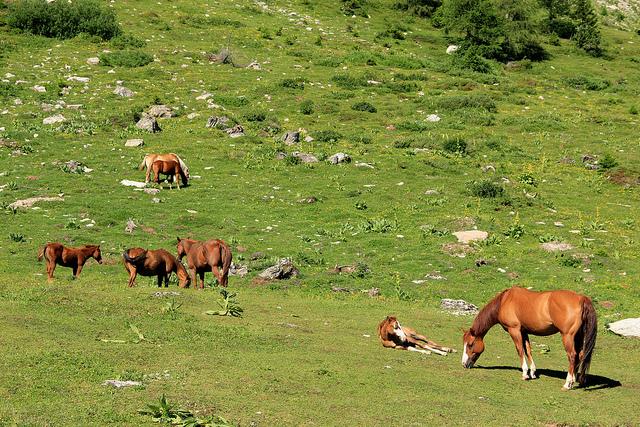What color is the horses?
Write a very short answer. Brown. What is the name of this animal?
Be succinct. Horse. What are the horses grazing on?
Give a very brief answer. Grass. 